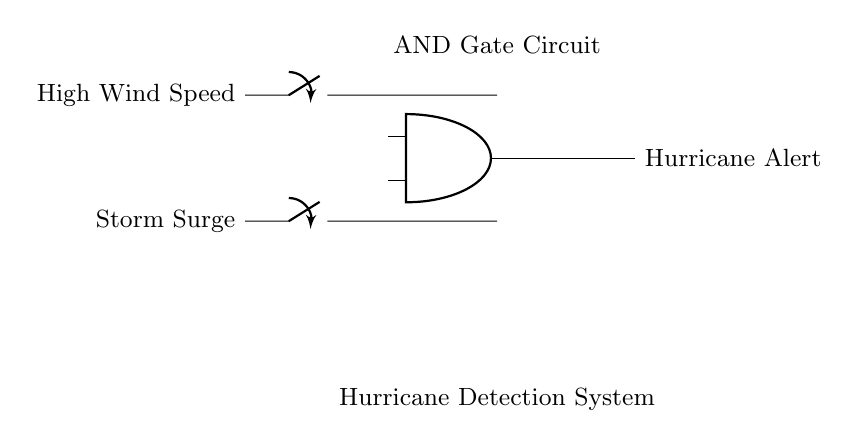What type of gate is used in this circuit? The circuit uses an AND gate, which is indicated by the symbol labeled as "AND gate" in the diagram. It shows that the output only activates when both inputs are high.
Answer: AND gate What are the inputs to the AND gate? The inputs to the AND gate are "High Wind Speed" and "Storm Surge," which are the two switches leading into the gate in the circuit diagram.
Answer: High Wind Speed, Storm Surge What signal is generated at the output of the AND gate? The output signal of the AND gate is "Hurricane Alert," which is represented on the right side of the gate in the circuit diagram. It indicates that a hurricane alert is triggered when both inputs are active.
Answer: Hurricane Alert What condition causes the hurricane alert to be triggered? The hurricane alert is triggered when both input conditions, "High Wind Speed" and "Storm Surge," are true or activated, indicating that both dangerous weather conditions are present simultaneously.
Answer: Both high wind speed and storm surge How many inputs are there to the AND gate in this circuit? There are two inputs to the AND gate, as indicated by the two switches connected to it in the diagram, each representing a different condition.
Answer: 2 What role does the AND gate play in this circuit? The AND gate functions as a logical operation that determines if both conditions (high wind speed and storm surge) are met to trigger an output, which is the alert for a hurricane.
Answer: Logical operation 